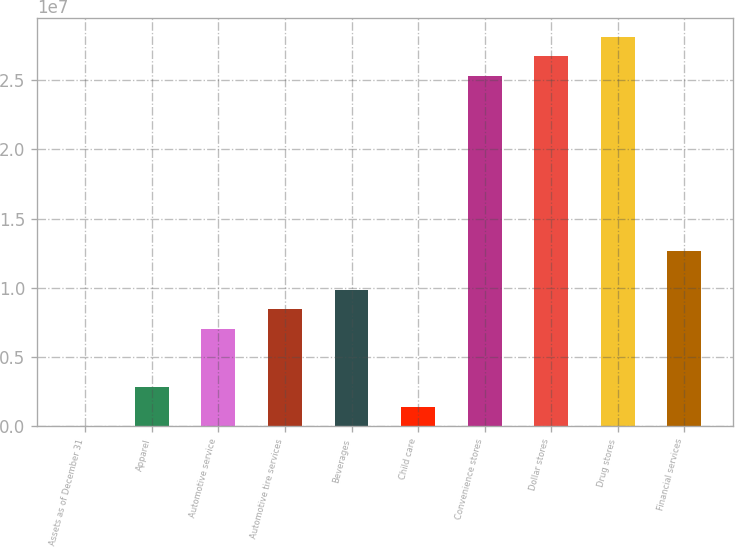Convert chart to OTSL. <chart><loc_0><loc_0><loc_500><loc_500><bar_chart><fcel>Assets as of December 31<fcel>Apparel<fcel>Automotive service<fcel>Automotive tire services<fcel>Beverages<fcel>Child care<fcel>Convenience stores<fcel>Dollar stores<fcel>Drug stores<fcel>Financial services<nl><fcel>2017<fcel>2.81325e+06<fcel>7.03009e+06<fcel>8.43571e+06<fcel>9.84132e+06<fcel>1.40763e+06<fcel>2.53031e+07<fcel>2.67087e+07<fcel>2.81143e+07<fcel>1.26526e+07<nl></chart> 